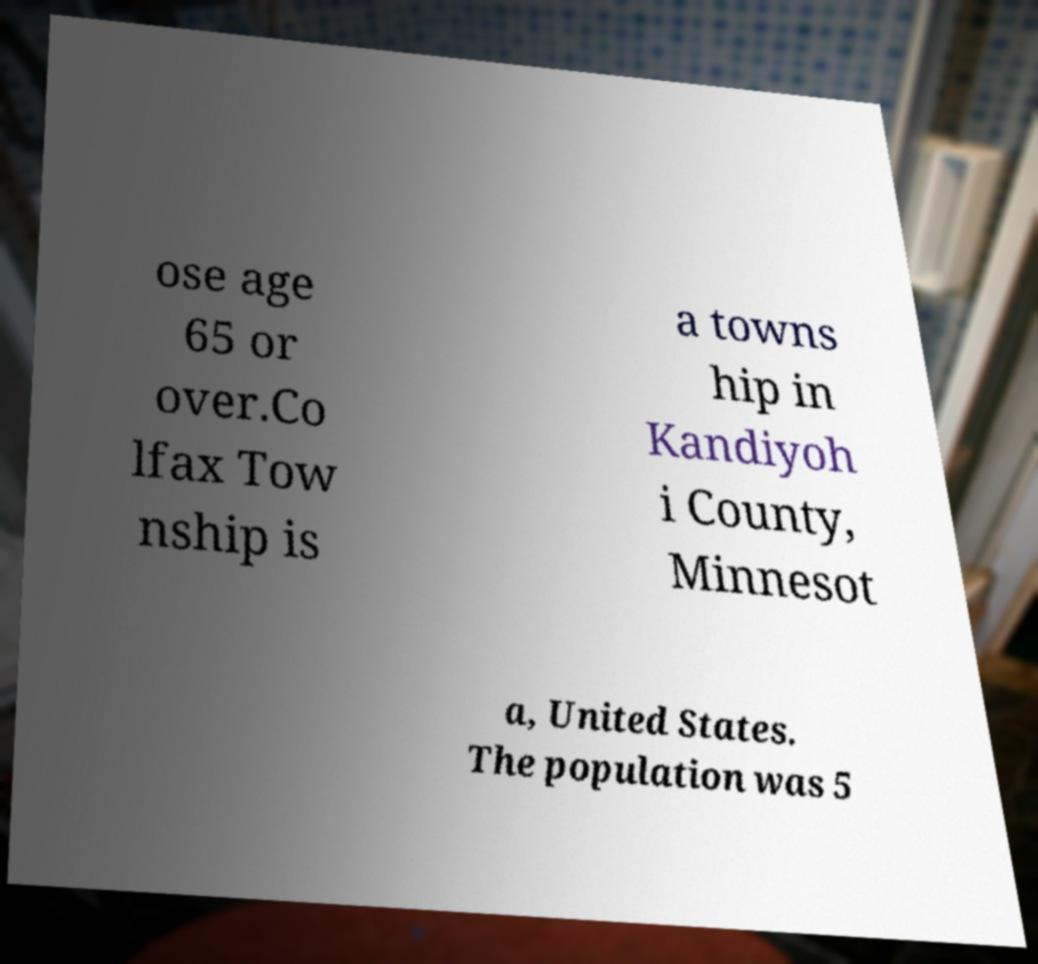What messages or text are displayed in this image? I need them in a readable, typed format. ose age 65 or over.Co lfax Tow nship is a towns hip in Kandiyoh i County, Minnesot a, United States. The population was 5 